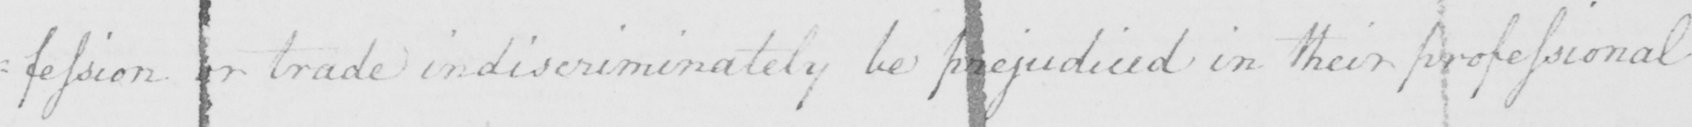Transcribe the text shown in this historical manuscript line. : fession or trade indiscriminately be prejudiced in their professional 